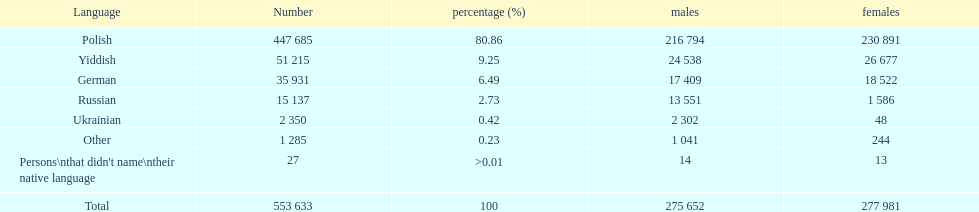In the płock governorate, which language was spoken by only .42% of individuals according to the 1897 imperial census? Ukrainian. 